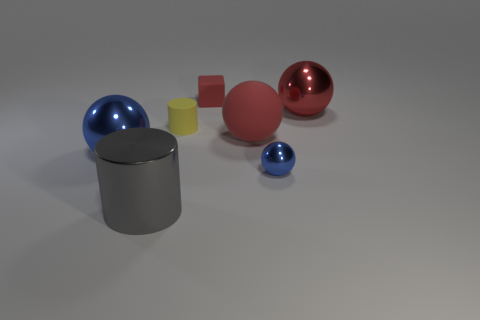Subtract all gray cylinders. How many red spheres are left? 2 Subtract 1 spheres. How many spheres are left? 3 Subtract all matte balls. How many balls are left? 3 Add 1 large matte balls. How many objects exist? 8 Subtract all spheres. How many objects are left? 3 Subtract all gray spheres. Subtract all red cylinders. How many spheres are left? 4 Subtract all red balls. Subtract all big matte things. How many objects are left? 4 Add 6 yellow rubber cylinders. How many yellow rubber cylinders are left? 7 Add 4 small green metallic blocks. How many small green metallic blocks exist? 4 Subtract 2 blue spheres. How many objects are left? 5 